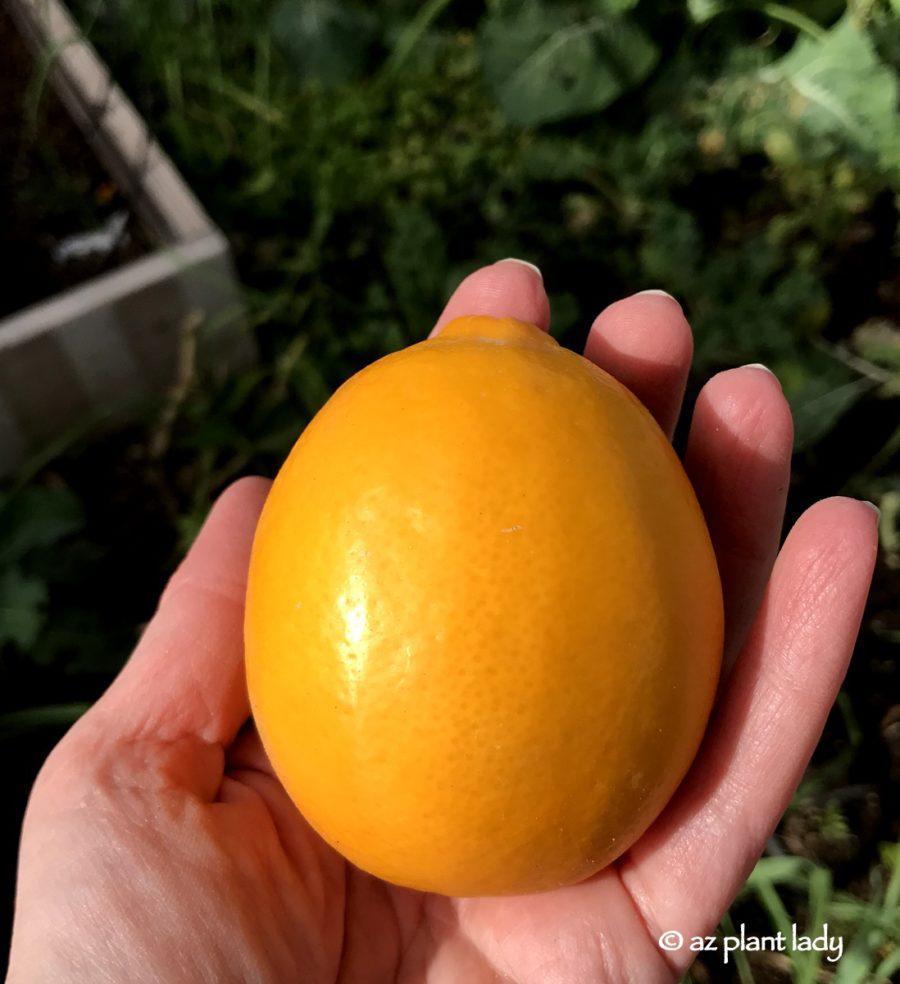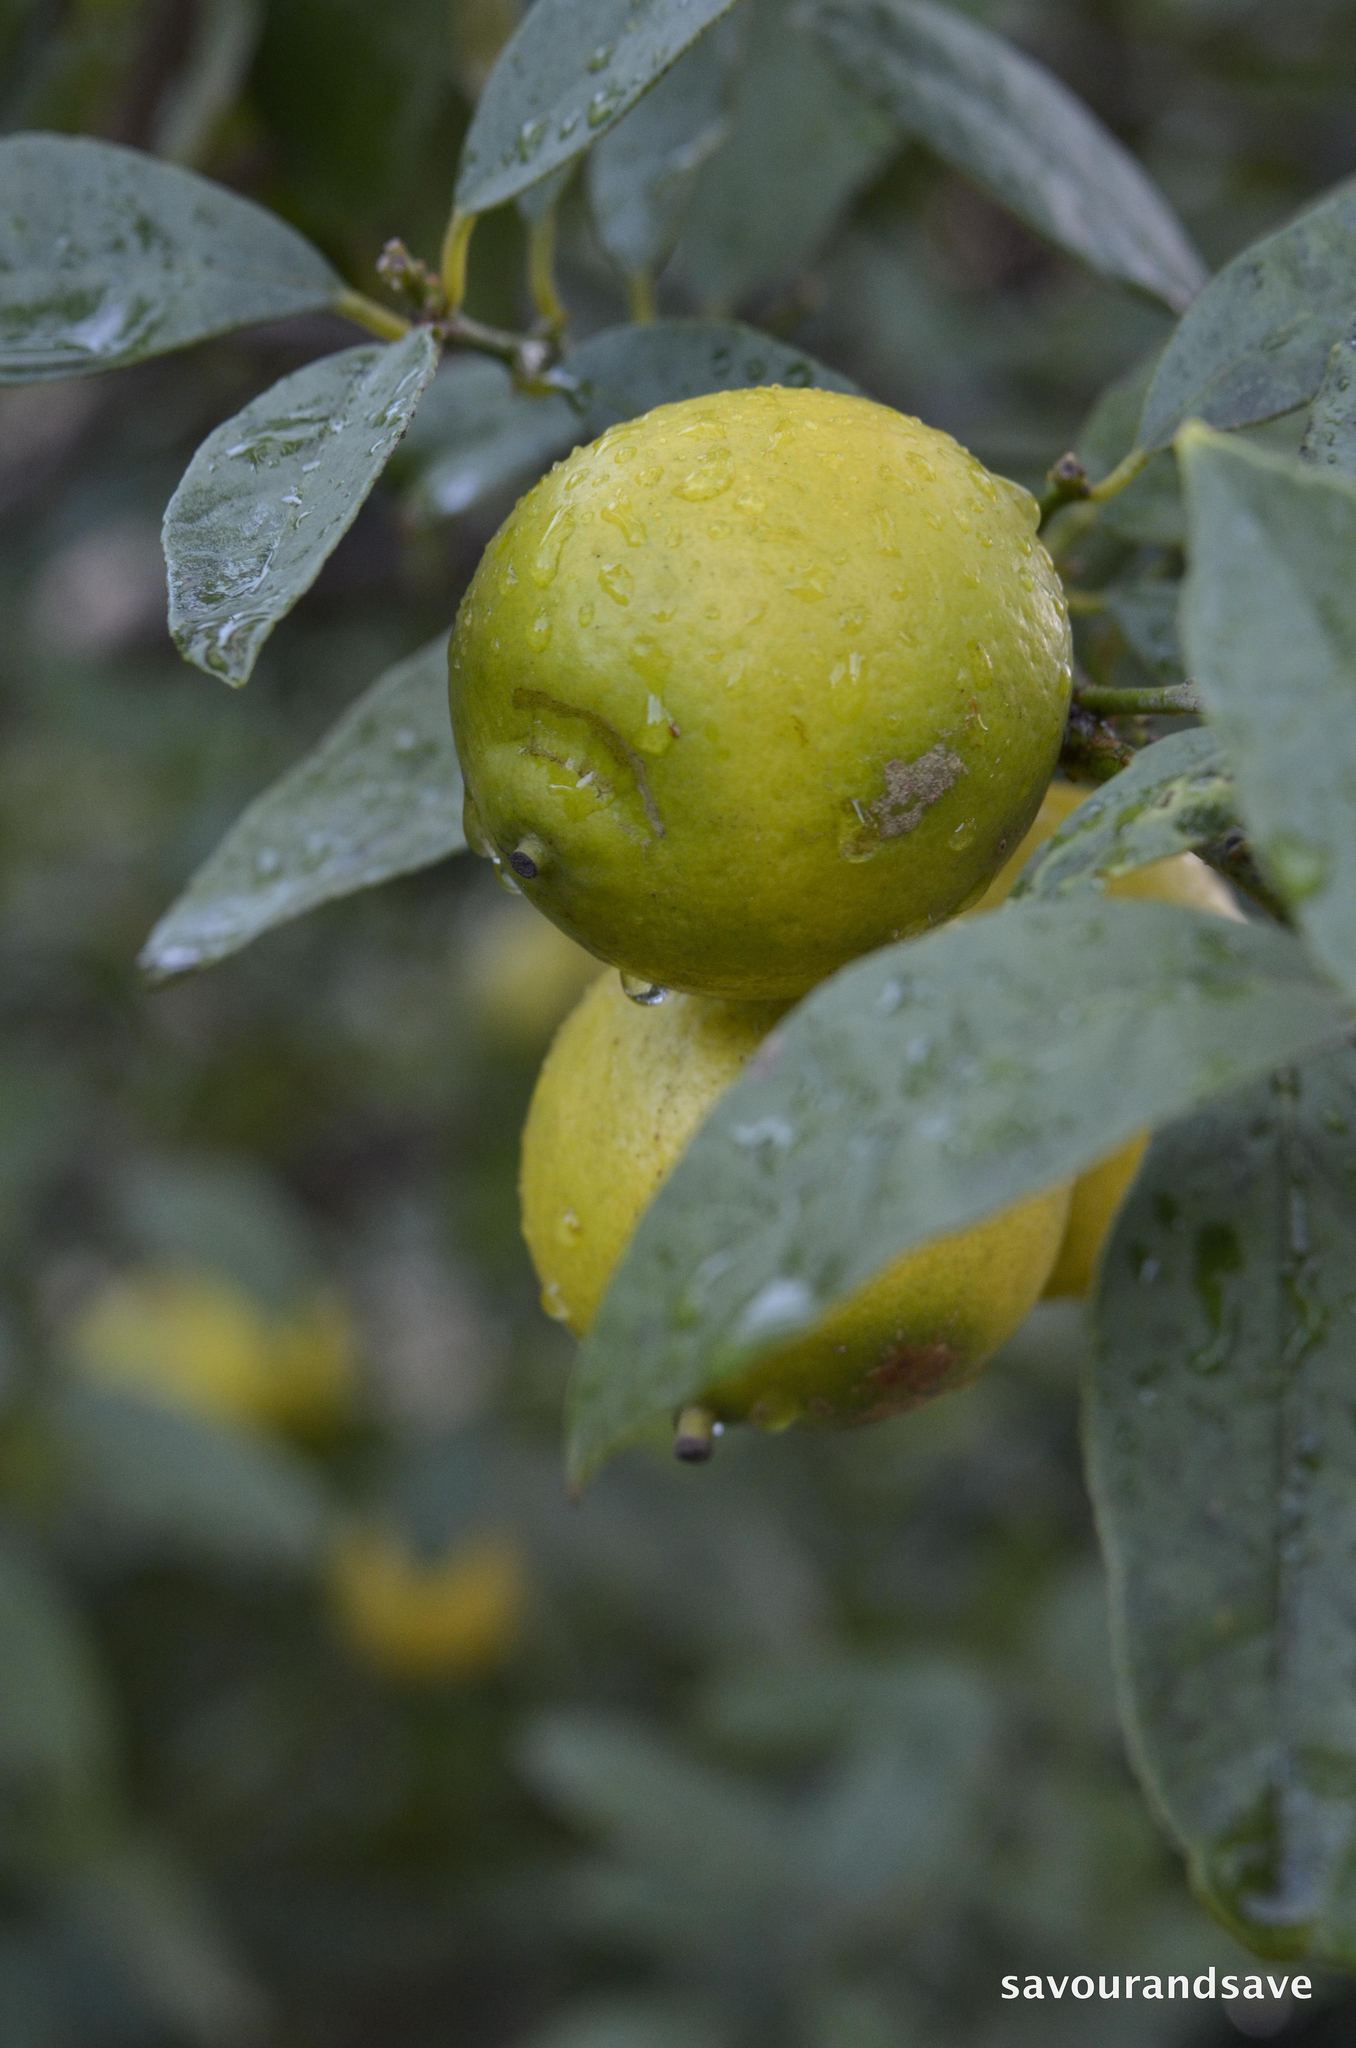The first image is the image on the left, the second image is the image on the right. For the images shown, is this caption "One image shows multiple lemons still on their tree, while the other image shows multiple lemons that have been picked from the tree but still have a few leaves with them." true? Answer yes or no. No. 